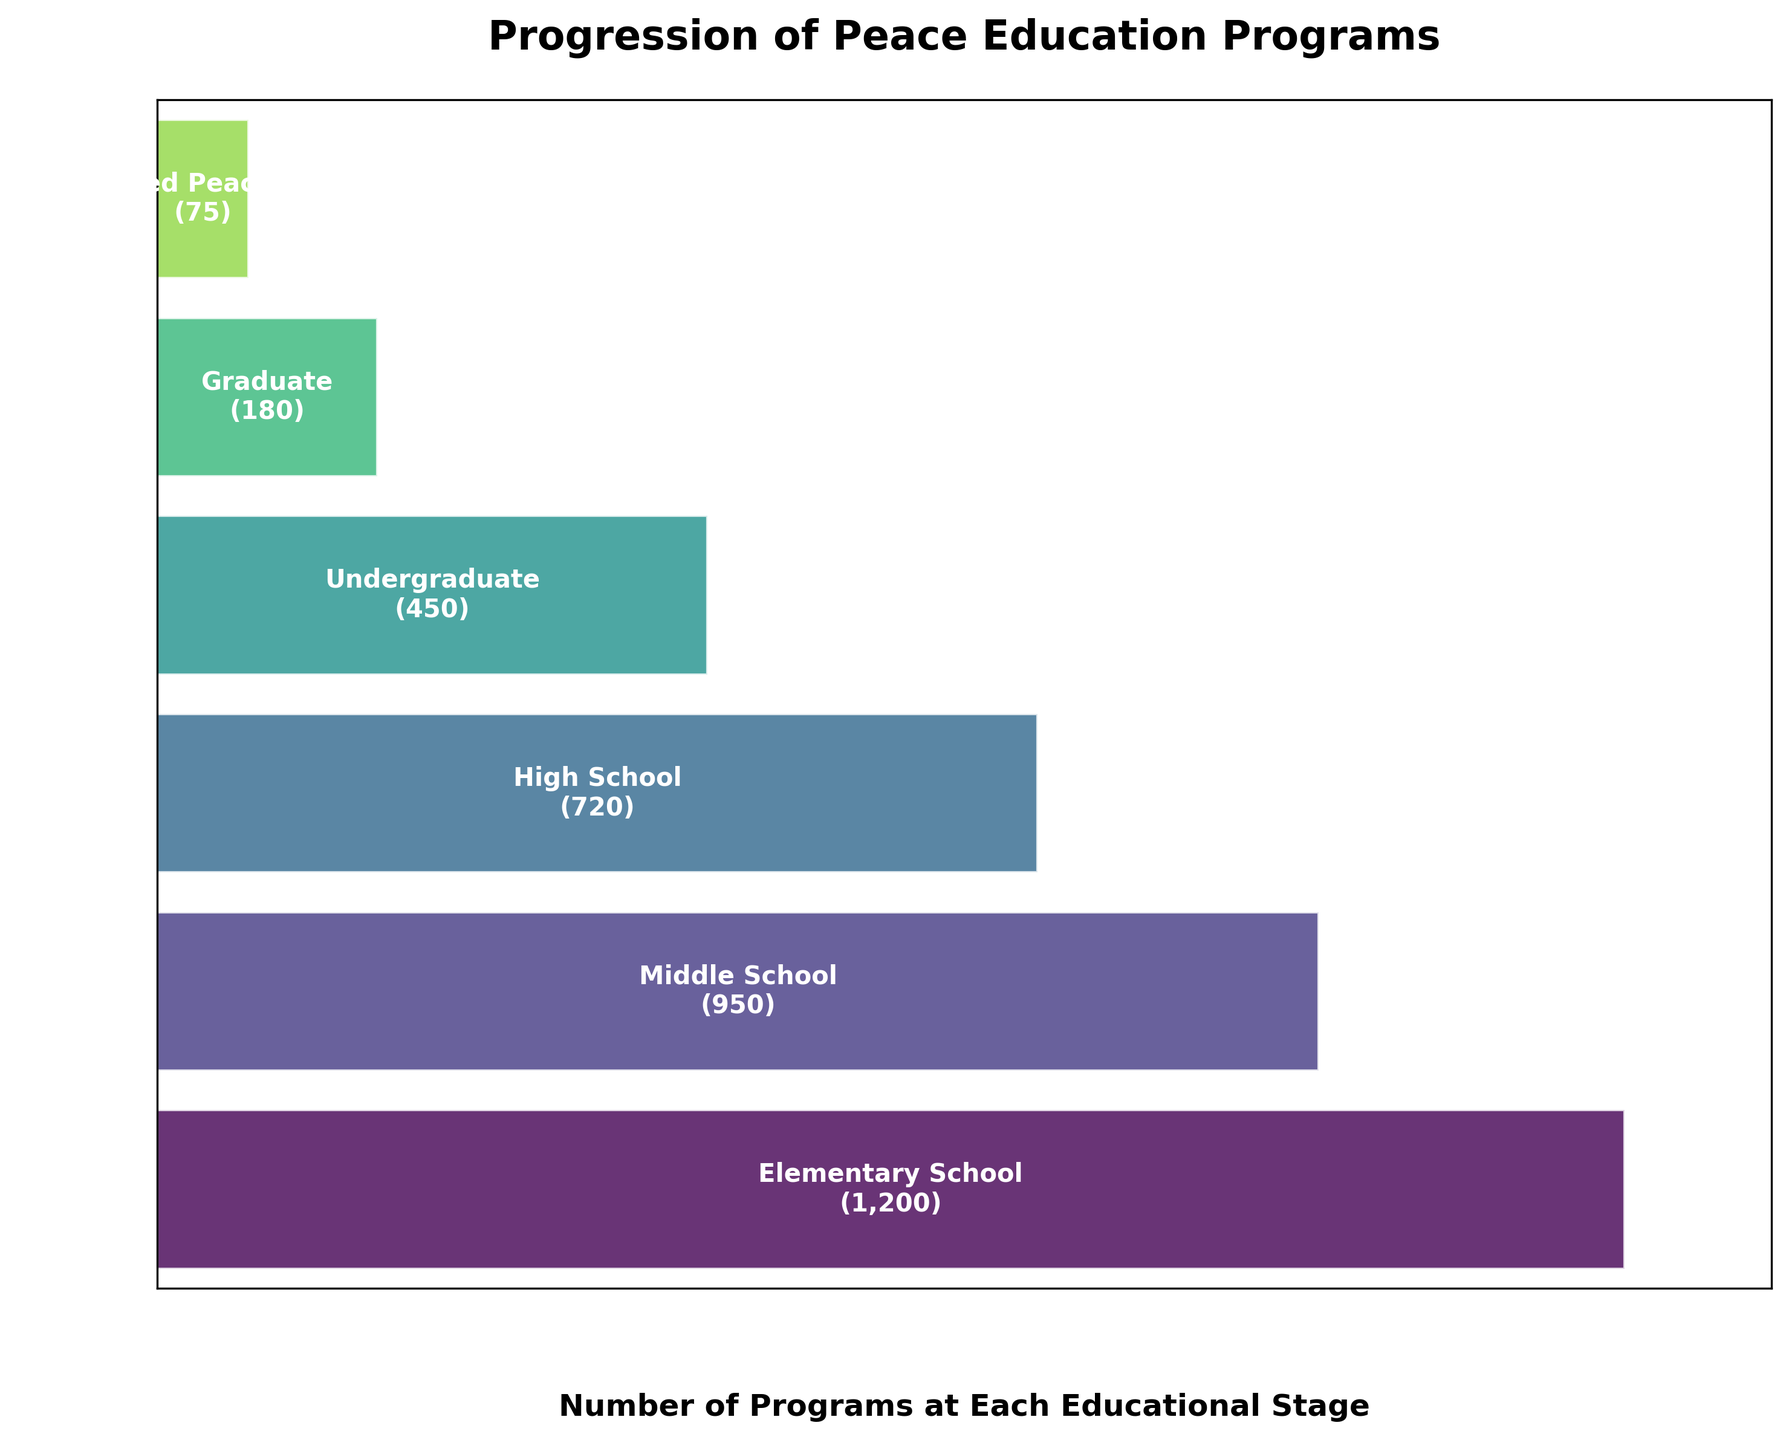What is the title of the plot? The title is displayed at the top of the chart in bold text.
Answer: Progression of Peace Education Programs Which educational stage has the highest number of peace education programs? The educational stage with the widest bar at the top represents the highest number of programs.
Answer: Elementary School By how many programs does the number of peace education programs decrease from Middle School to High School? The number of programs at Middle School is 950, and at High School, it is 720. The decrease is calculated by subtracting 720 from 950.
Answer: 230 What color is used to represent the Graduate stage on the funnel chart? Each stage is represented by bars shaded in green, with the intensity changing as the stages progress down. Graduate stage has a slightly lighter shade nearing the bottom.
Answer: Light green How many stages are displayed in the funnel chart? Counting the number of distinct bars from top to bottom in the chart represents the total stages.
Answer: 6 What is the combined number of programs for Undergraduate and Graduate stages? The number of programs at the Undergraduate stage is 450, and for Graduate, it is 180. Summing these values gives the total.
Answer: 630 What percentage of the total number of Elementary School programs are there at the Specialized Peace Studies stage? The number of programs at Elementary School is 1200, and at Specialized Peace Studies, it is 75. The percentage is calculated using (75/1200) * 100.
Answer: 6.25% How does the number of programs at High School compare to those at Undergraduate? The number of programs at High School is 720, and at Undergraduate, it is 450. To compare, check if 720 is greater than 450.
Answer: High School has more Which educational stage has the second least number of peace education programs? By observing the bars from bottom to top, the second shortest bar represents the Graduate stage.
Answer: Graduate 